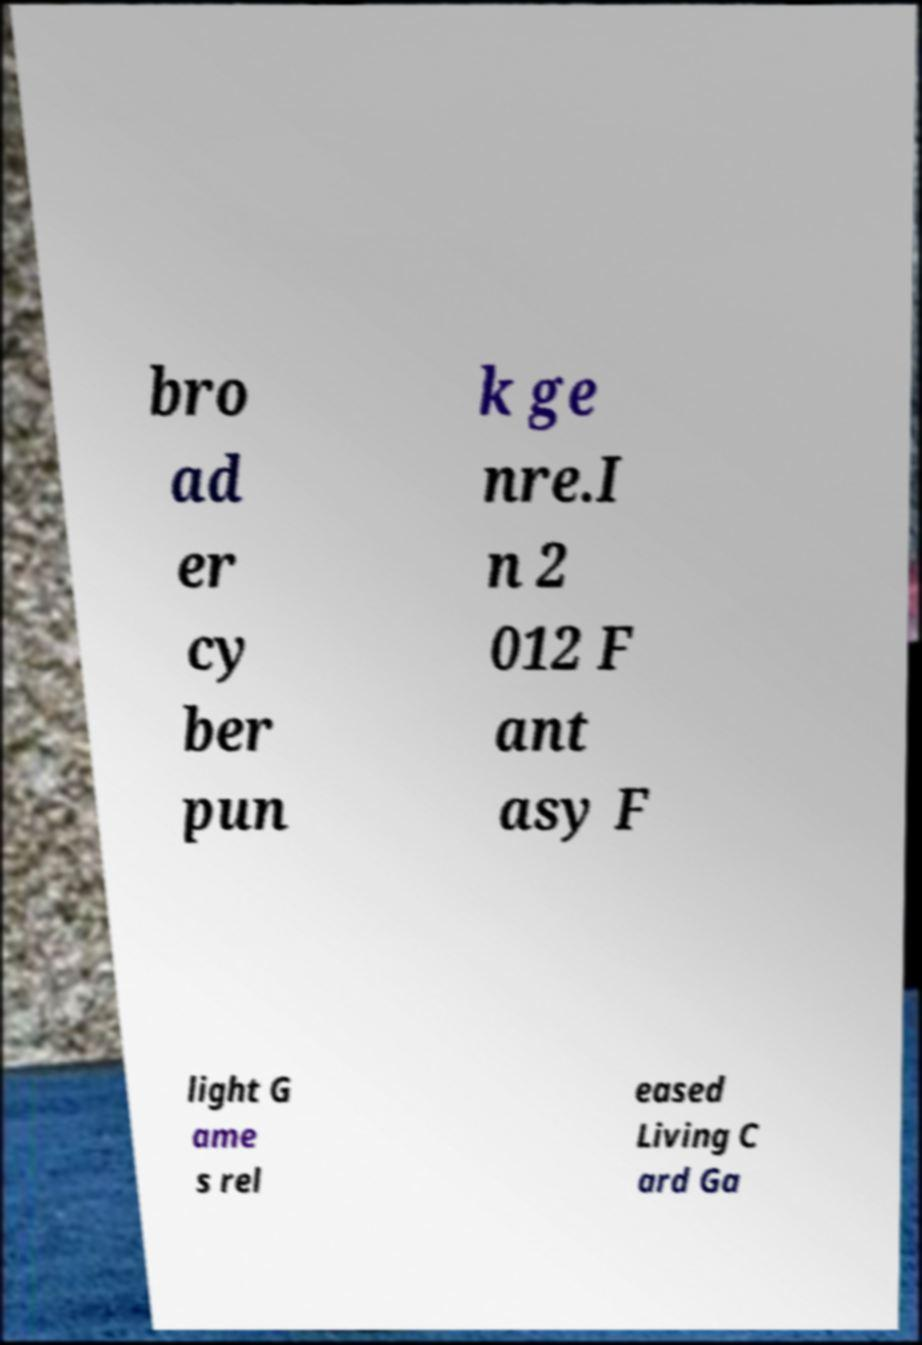What messages or text are displayed in this image? I need them in a readable, typed format. bro ad er cy ber pun k ge nre.I n 2 012 F ant asy F light G ame s rel eased Living C ard Ga 